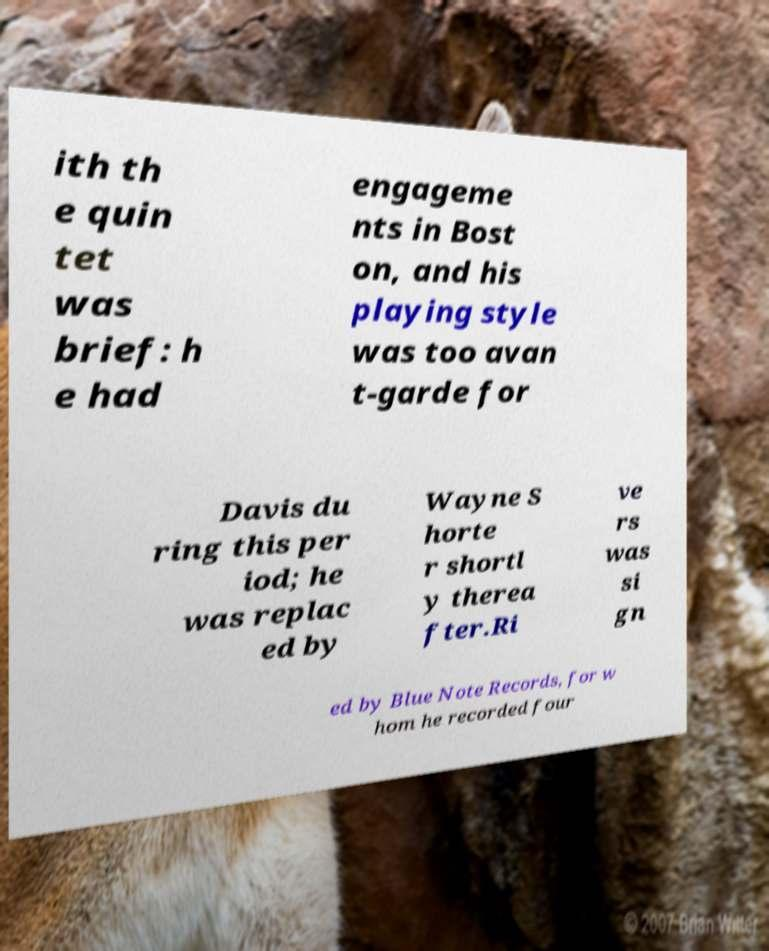Could you assist in decoding the text presented in this image and type it out clearly? ith th e quin tet was brief: h e had engageme nts in Bost on, and his playing style was too avan t-garde for Davis du ring this per iod; he was replac ed by Wayne S horte r shortl y therea fter.Ri ve rs was si gn ed by Blue Note Records, for w hom he recorded four 